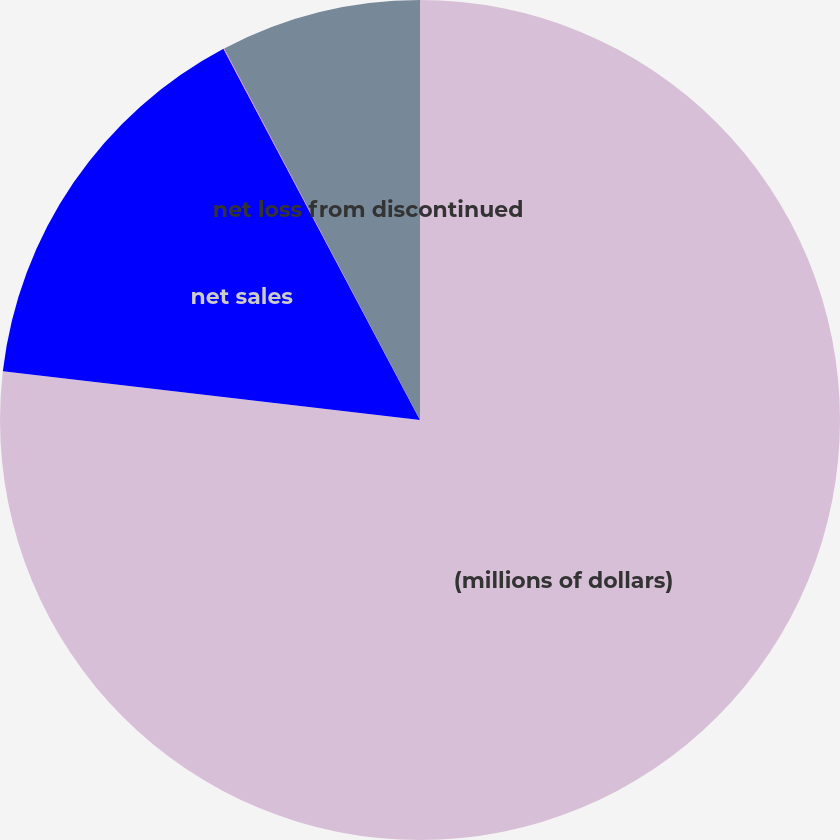<chart> <loc_0><loc_0><loc_500><loc_500><pie_chart><fcel>(millions of dollars)<fcel>net sales<fcel>Income taxes<fcel>net loss from discontinued<nl><fcel>76.85%<fcel>15.4%<fcel>0.03%<fcel>7.72%<nl></chart> 